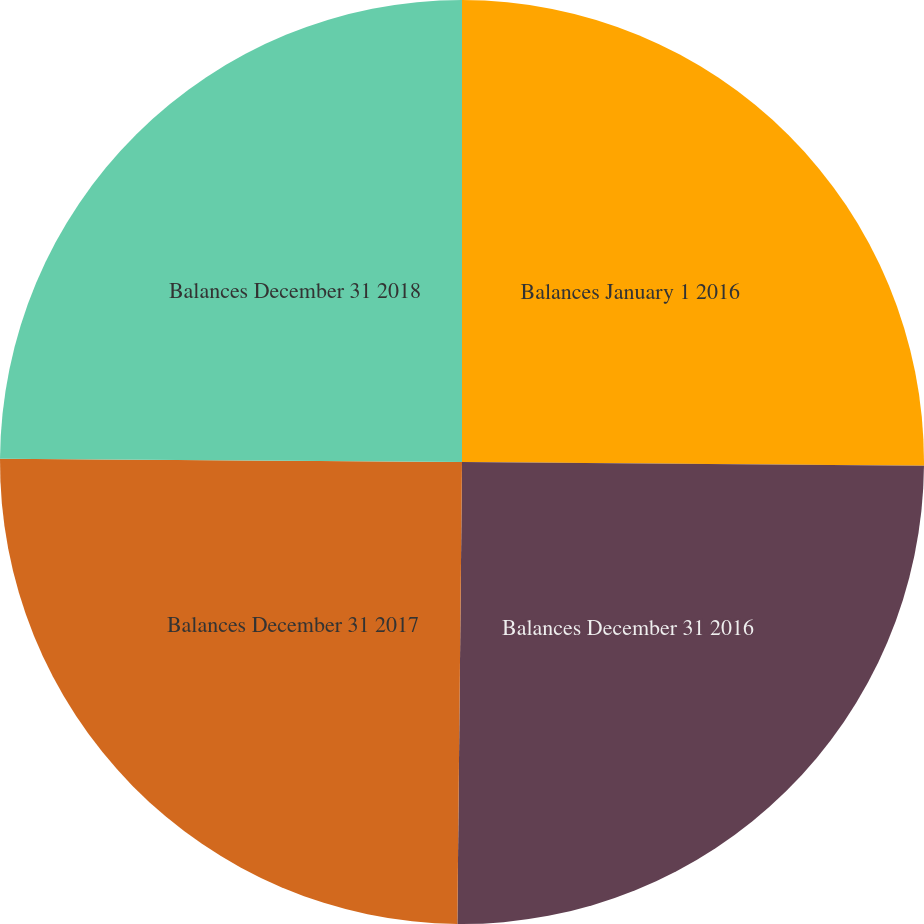Convert chart to OTSL. <chart><loc_0><loc_0><loc_500><loc_500><pie_chart><fcel>Balances January 1 2016<fcel>Balances December 31 2016<fcel>Balances December 31 2017<fcel>Balances December 31 2018<nl><fcel>25.13%<fcel>25.03%<fcel>24.95%<fcel>24.89%<nl></chart> 